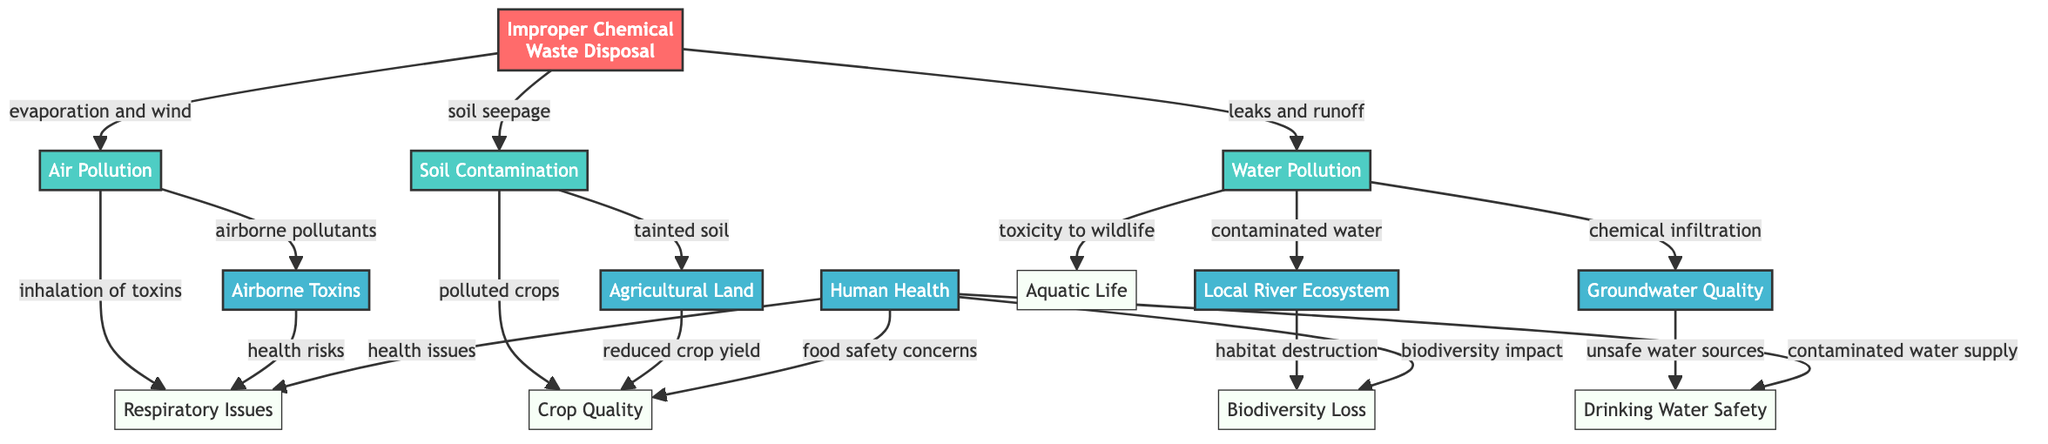What is the root cause of the diagram? The root cause node is labeled "Improper Chemical Waste Disposal," which indicates that this is the primary issue leading to various environmental impacts.
Answer: Improper Chemical Waste Disposal How many main consequence nodes are there? Upon examining the diagram, there are three main consequence nodes listed: "Water Pollution," "Soil Contamination," and "Air Pollution."
Answer: 3 What happens as a result of water pollution? Water pollution directly leads to "Local River Ecosystem" and "Groundwater Quality," indicating how the contaminated water affects these essential components of the environment.
Answer: Local River Ecosystem, Groundwater Quality Which node represents the impact on human health? The node that encompasses the human health impacts from the consequences of chemical waste is marked as "Human Health," showing that it is an outcome linked to water, soil, and air pollution.
Answer: Human Health What are the consequences of soil contamination? From the "Soil Contamination" node, the outcomes include "Agricultural Land" and "Polluted Crops," demonstrating how soil quality directly impacts agricultural productivity and safety.
Answer: Agricultural Land, Polluted Crops How is air pollution linked to human health? The "Air Pollution" node connects to "Inhalation of Toxins," which shows how airborne pollutants can lead to serious health issues for humans.
Answer: Inhalation of Toxins What specific health issues are associated with improper chemical waste disposal? The diagram highlights "Respiratory Issues" as a direct consequence of harmful chemical exposure from improper disposal, indicating a significant impact on public health.
Answer: Respiratory Issues Which ecosystem aspect is threatened by water pollution? The impact of water pollution on ecosystems is evidenced by the connection to "Aquatic Life," showing how contaminated water affects biodiversity in aquatic environments.
Answer: Aquatic Life What environmental element is connected to airborne pollutants? The "Air Pollution" leads to the generation of "Airborne Toxins," revealing how pollution infiltrates the atmosphere, creating further risks to both environmental and human health.
Answer: Airborne Toxins 